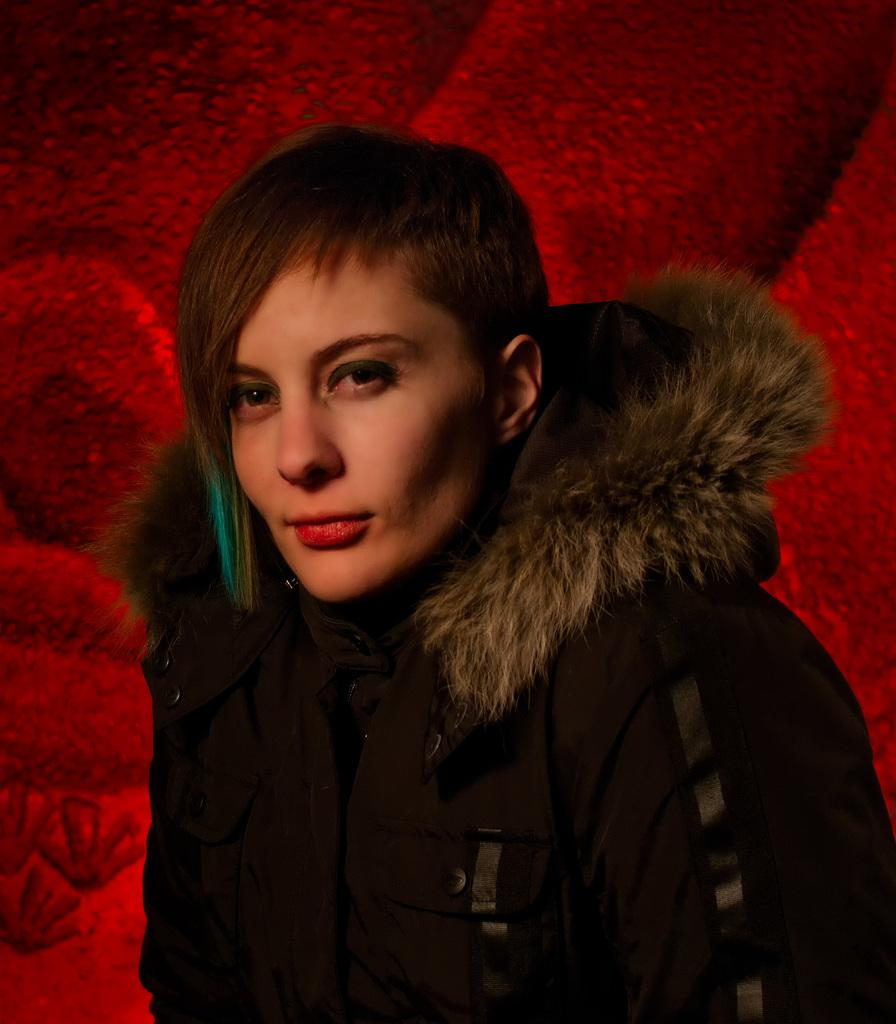Who or what is the main subject in the image? There is a person in the image. What is the person wearing? The person is wearing a jacket. Where is the person located in the image? The person is located in the center of the image. What type of quiver is the person holding in the image? There is no quiver present in the image; the person is wearing a jacket. 